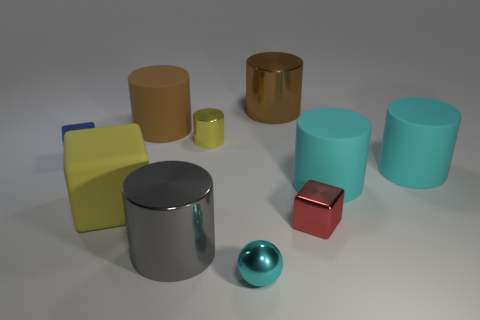There is a small cube behind the block in front of the large matte cube; what number of big metallic things are behind it?
Offer a terse response. 1. The tiny block that is the same material as the tiny blue thing is what color?
Provide a short and direct response. Red. Do the metallic block right of the cyan metallic sphere and the big yellow rubber cube have the same size?
Offer a terse response. No. How many things are metal spheres or tiny metallic things?
Your response must be concise. 4. The tiny ball that is in front of the tiny shiny cube in front of the shiny cube that is behind the tiny red metal thing is made of what material?
Ensure brevity in your answer.  Metal. There is a small cube left of the tiny yellow metallic thing; what is its material?
Ensure brevity in your answer.  Metal. Is there a red rubber cylinder that has the same size as the gray metal cylinder?
Your response must be concise. No. There is a tiny metallic cube to the right of the big gray cylinder; is its color the same as the shiny sphere?
Make the answer very short. No. How many cyan objects are metal cylinders or metal objects?
Ensure brevity in your answer.  1. How many tiny objects are the same color as the big cube?
Your answer should be compact. 1. 